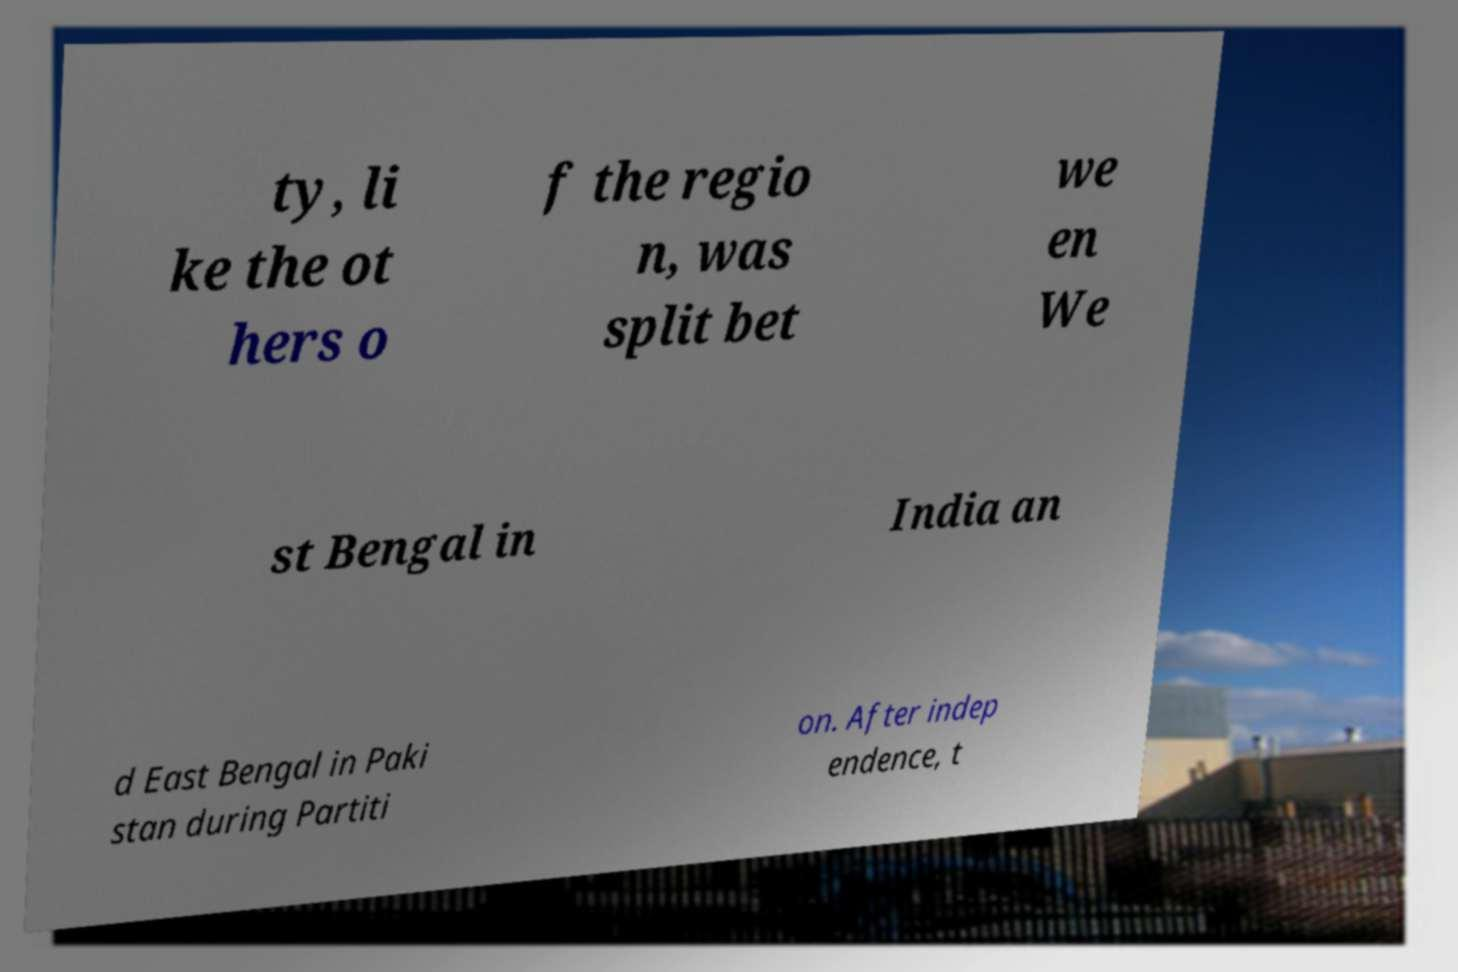There's text embedded in this image that I need extracted. Can you transcribe it verbatim? ty, li ke the ot hers o f the regio n, was split bet we en We st Bengal in India an d East Bengal in Paki stan during Partiti on. After indep endence, t 